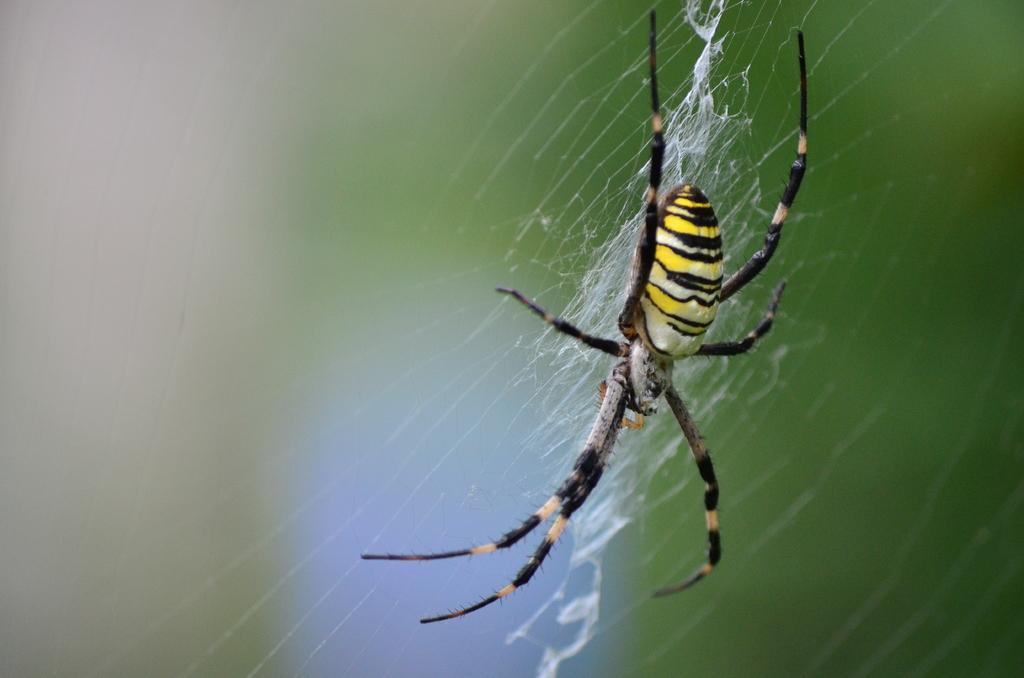What is the main subject of the image? The main subject of the image is a spider. What is the spider doing in the image? The spider is crawling on a web. How many family units can be seen in the image? There are no family units present in the image, as it features a spider crawling on a web. What type of giants can be seen in the image? There are no giants present in the image; it features a spider crawling on a web. 